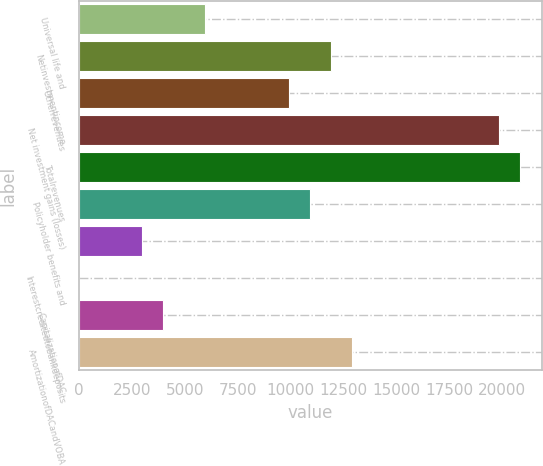Convert chart to OTSL. <chart><loc_0><loc_0><loc_500><loc_500><bar_chart><fcel>Universal life and<fcel>Netinvestmentincome<fcel>Otherrevenues<fcel>Net investment gains (losses)<fcel>Totalrevenues<fcel>Policyholder benefits and<fcel>Unnamed: 6<fcel>Interestcreditedtobankdeposits<fcel>CapitalizationofDAC<fcel>AmortizationofDACandVOBA<nl><fcel>5956.8<fcel>11910.6<fcel>9926<fcel>19849<fcel>20841.3<fcel>10918.3<fcel>2979.9<fcel>3<fcel>3972.2<fcel>12902.9<nl></chart> 